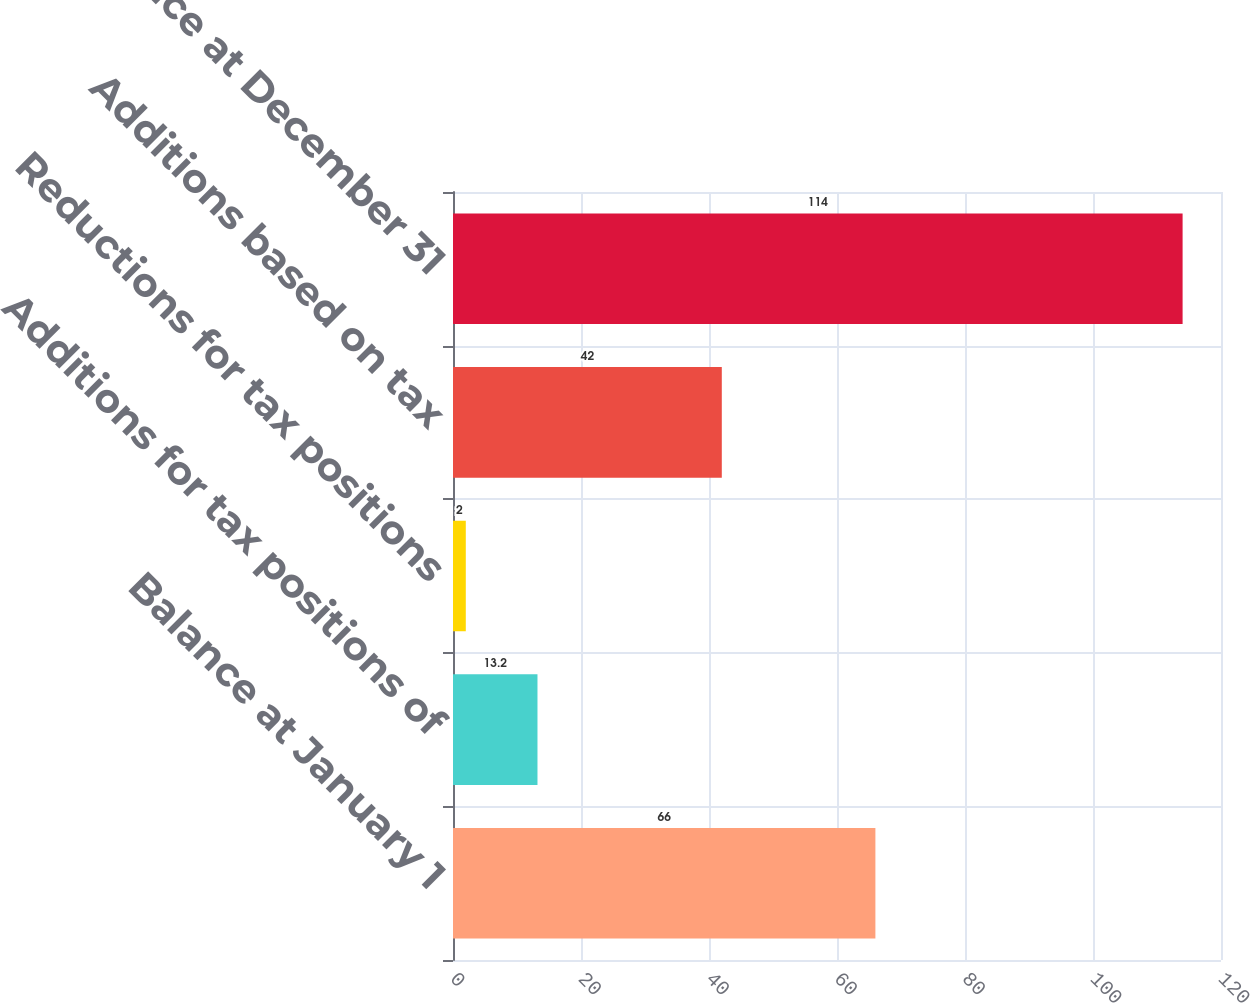Convert chart. <chart><loc_0><loc_0><loc_500><loc_500><bar_chart><fcel>Balance at January 1<fcel>Additions for tax positions of<fcel>Reductions for tax positions<fcel>Additions based on tax<fcel>Balance at December 31<nl><fcel>66<fcel>13.2<fcel>2<fcel>42<fcel>114<nl></chart> 